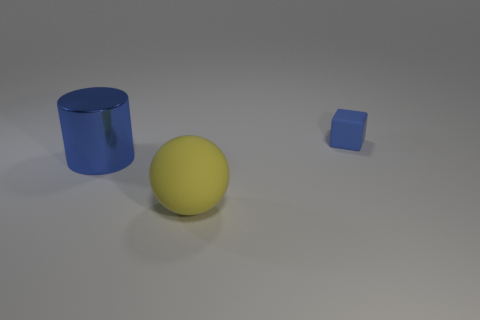Subtract 1 blocks. How many blocks are left? 0 Add 1 yellow rubber balls. How many objects exist? 4 Subtract all blocks. How many objects are left? 2 Add 2 big green cylinders. How many big green cylinders exist? 2 Subtract 0 blue balls. How many objects are left? 3 Subtract all blue balls. Subtract all brown cylinders. How many balls are left? 1 Subtract all large things. Subtract all tiny blue matte objects. How many objects are left? 0 Add 3 blue metal things. How many blue metal things are left? 4 